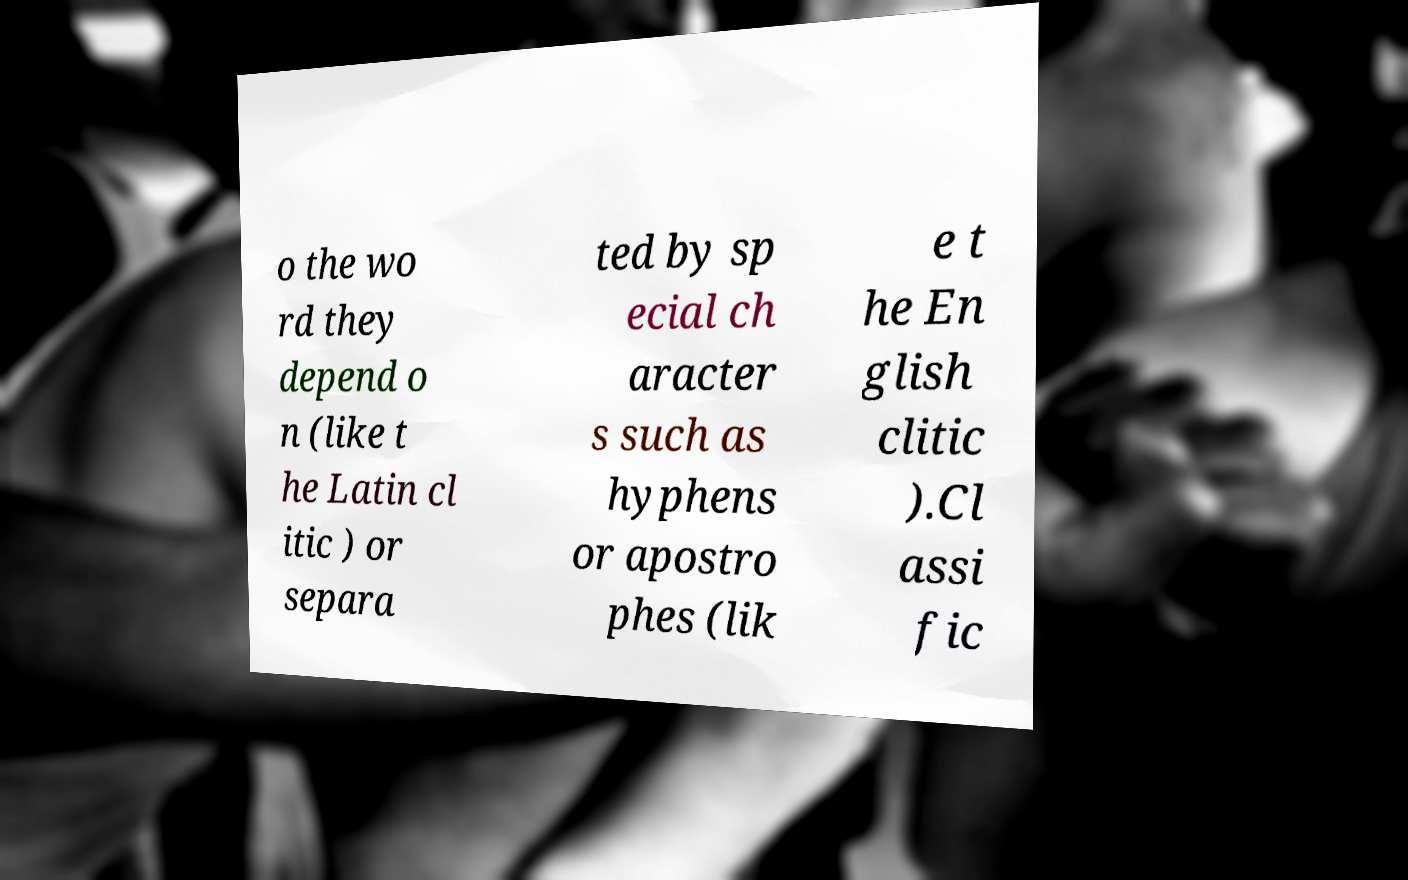I need the written content from this picture converted into text. Can you do that? o the wo rd they depend o n (like t he Latin cl itic ) or separa ted by sp ecial ch aracter s such as hyphens or apostro phes (lik e t he En glish clitic ).Cl assi fic 